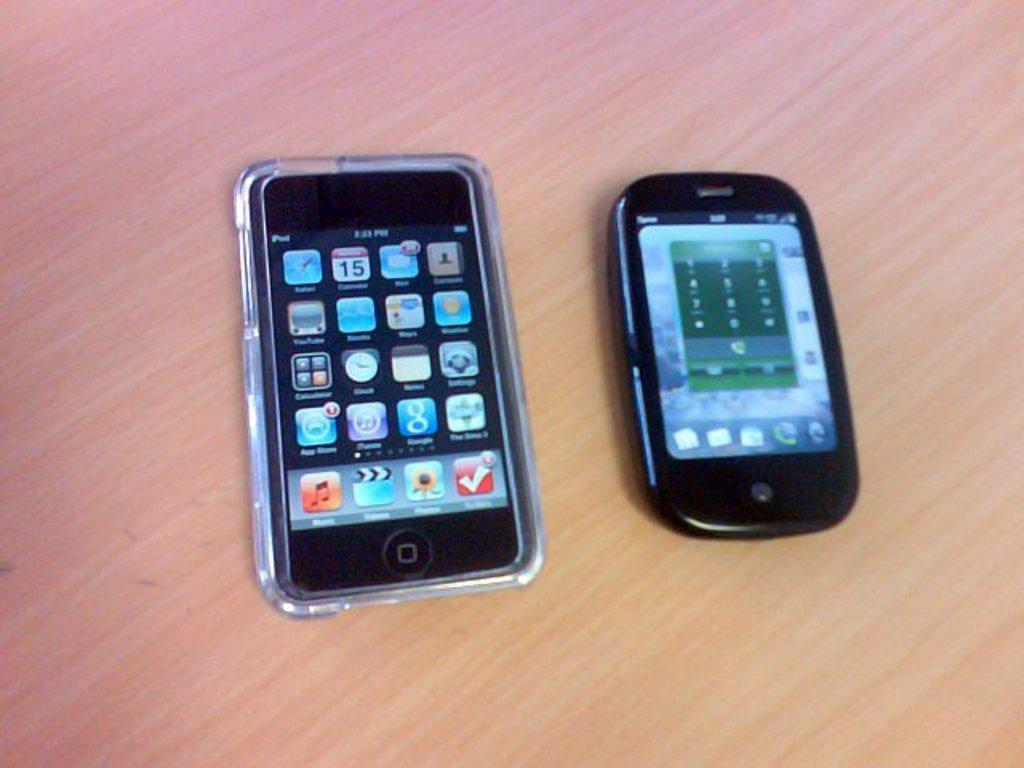<image>
Describe the image concisely. a phone with an iTunes logo on it 